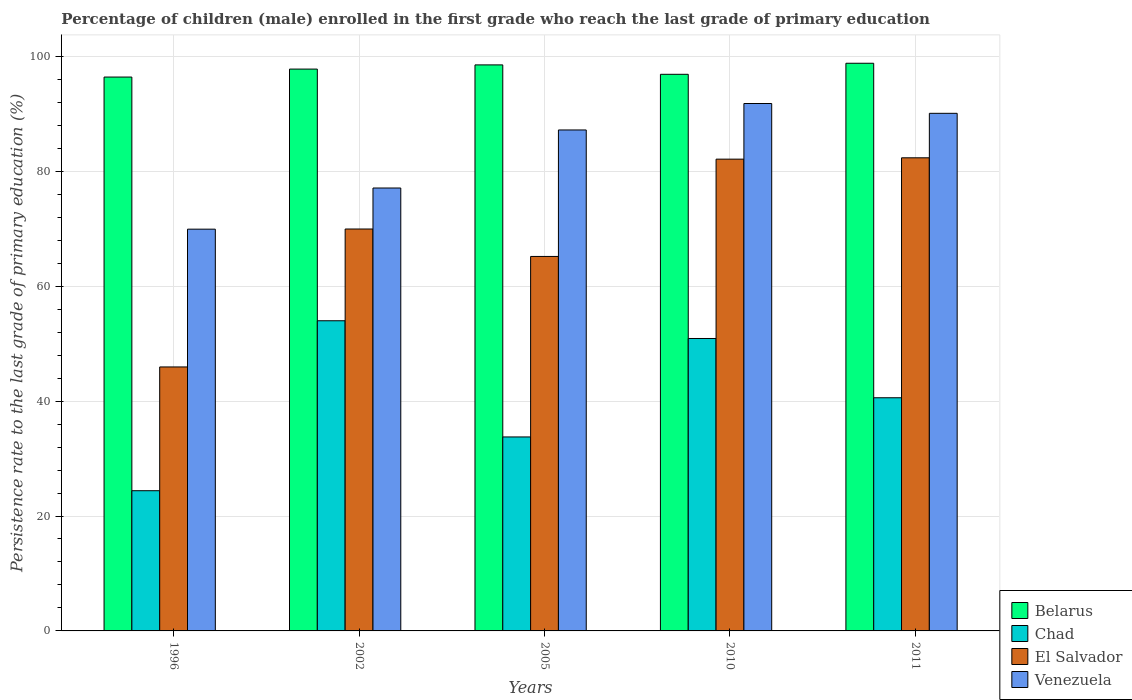Are the number of bars on each tick of the X-axis equal?
Offer a terse response. Yes. How many bars are there on the 4th tick from the left?
Give a very brief answer. 4. How many bars are there on the 2nd tick from the right?
Your response must be concise. 4. What is the label of the 1st group of bars from the left?
Provide a succinct answer. 1996. What is the persistence rate of children in Venezuela in 2011?
Give a very brief answer. 90.09. Across all years, what is the maximum persistence rate of children in Chad?
Your answer should be very brief. 53.99. Across all years, what is the minimum persistence rate of children in Chad?
Your answer should be compact. 24.4. In which year was the persistence rate of children in El Salvador maximum?
Make the answer very short. 2011. What is the total persistence rate of children in Chad in the graph?
Ensure brevity in your answer.  203.63. What is the difference between the persistence rate of children in Chad in 1996 and that in 2002?
Offer a very short reply. -29.58. What is the difference between the persistence rate of children in El Salvador in 2011 and the persistence rate of children in Venezuela in 2002?
Offer a very short reply. 5.26. What is the average persistence rate of children in Venezuela per year?
Your answer should be compact. 83.22. In the year 2011, what is the difference between the persistence rate of children in Chad and persistence rate of children in Venezuela?
Provide a short and direct response. -49.51. What is the ratio of the persistence rate of children in Belarus in 2002 to that in 2010?
Your answer should be very brief. 1.01. Is the persistence rate of children in Belarus in 2002 less than that in 2005?
Give a very brief answer. Yes. What is the difference between the highest and the second highest persistence rate of children in Belarus?
Give a very brief answer. 0.28. What is the difference between the highest and the lowest persistence rate of children in Venezuela?
Make the answer very short. 21.87. In how many years, is the persistence rate of children in Belarus greater than the average persistence rate of children in Belarus taken over all years?
Your answer should be compact. 3. Is it the case that in every year, the sum of the persistence rate of children in Venezuela and persistence rate of children in Belarus is greater than the sum of persistence rate of children in Chad and persistence rate of children in El Salvador?
Keep it short and to the point. No. What does the 3rd bar from the left in 2011 represents?
Keep it short and to the point. El Salvador. What does the 4th bar from the right in 2005 represents?
Your answer should be very brief. Belarus. Is it the case that in every year, the sum of the persistence rate of children in El Salvador and persistence rate of children in Belarus is greater than the persistence rate of children in Chad?
Keep it short and to the point. Yes. How many bars are there?
Your answer should be compact. 20. How many years are there in the graph?
Ensure brevity in your answer.  5. What is the difference between two consecutive major ticks on the Y-axis?
Your answer should be very brief. 20. Are the values on the major ticks of Y-axis written in scientific E-notation?
Provide a short and direct response. No. Does the graph contain any zero values?
Make the answer very short. No. Does the graph contain grids?
Ensure brevity in your answer.  Yes. What is the title of the graph?
Provide a short and direct response. Percentage of children (male) enrolled in the first grade who reach the last grade of primary education. What is the label or title of the Y-axis?
Provide a succinct answer. Persistence rate to the last grade of primary education (%). What is the Persistence rate to the last grade of primary education (%) in Belarus in 1996?
Your answer should be compact. 96.4. What is the Persistence rate to the last grade of primary education (%) of Chad in 1996?
Your answer should be compact. 24.4. What is the Persistence rate to the last grade of primary education (%) of El Salvador in 1996?
Make the answer very short. 45.94. What is the Persistence rate to the last grade of primary education (%) in Venezuela in 1996?
Provide a short and direct response. 69.92. What is the Persistence rate to the last grade of primary education (%) of Belarus in 2002?
Make the answer very short. 97.79. What is the Persistence rate to the last grade of primary education (%) of Chad in 2002?
Make the answer very short. 53.99. What is the Persistence rate to the last grade of primary education (%) of El Salvador in 2002?
Offer a terse response. 69.95. What is the Persistence rate to the last grade of primary education (%) in Venezuela in 2002?
Ensure brevity in your answer.  77.09. What is the Persistence rate to the last grade of primary education (%) in Belarus in 2005?
Make the answer very short. 98.52. What is the Persistence rate to the last grade of primary education (%) of Chad in 2005?
Give a very brief answer. 33.76. What is the Persistence rate to the last grade of primary education (%) of El Salvador in 2005?
Ensure brevity in your answer.  65.18. What is the Persistence rate to the last grade of primary education (%) in Venezuela in 2005?
Your answer should be compact. 87.19. What is the Persistence rate to the last grade of primary education (%) of Belarus in 2010?
Ensure brevity in your answer.  96.88. What is the Persistence rate to the last grade of primary education (%) in Chad in 2010?
Your answer should be compact. 50.9. What is the Persistence rate to the last grade of primary education (%) in El Salvador in 2010?
Keep it short and to the point. 82.11. What is the Persistence rate to the last grade of primary education (%) of Venezuela in 2010?
Make the answer very short. 91.8. What is the Persistence rate to the last grade of primary education (%) in Belarus in 2011?
Ensure brevity in your answer.  98.8. What is the Persistence rate to the last grade of primary education (%) in Chad in 2011?
Your answer should be very brief. 40.58. What is the Persistence rate to the last grade of primary education (%) in El Salvador in 2011?
Provide a succinct answer. 82.35. What is the Persistence rate to the last grade of primary education (%) in Venezuela in 2011?
Your answer should be very brief. 90.09. Across all years, what is the maximum Persistence rate to the last grade of primary education (%) of Belarus?
Provide a short and direct response. 98.8. Across all years, what is the maximum Persistence rate to the last grade of primary education (%) of Chad?
Ensure brevity in your answer.  53.99. Across all years, what is the maximum Persistence rate to the last grade of primary education (%) of El Salvador?
Make the answer very short. 82.35. Across all years, what is the maximum Persistence rate to the last grade of primary education (%) in Venezuela?
Give a very brief answer. 91.8. Across all years, what is the minimum Persistence rate to the last grade of primary education (%) of Belarus?
Offer a very short reply. 96.4. Across all years, what is the minimum Persistence rate to the last grade of primary education (%) in Chad?
Your answer should be compact. 24.4. Across all years, what is the minimum Persistence rate to the last grade of primary education (%) in El Salvador?
Your response must be concise. 45.94. Across all years, what is the minimum Persistence rate to the last grade of primary education (%) of Venezuela?
Your response must be concise. 69.92. What is the total Persistence rate to the last grade of primary education (%) of Belarus in the graph?
Offer a terse response. 488.39. What is the total Persistence rate to the last grade of primary education (%) in Chad in the graph?
Your answer should be compact. 203.63. What is the total Persistence rate to the last grade of primary education (%) in El Salvador in the graph?
Offer a very short reply. 345.53. What is the total Persistence rate to the last grade of primary education (%) of Venezuela in the graph?
Give a very brief answer. 416.09. What is the difference between the Persistence rate to the last grade of primary education (%) in Belarus in 1996 and that in 2002?
Provide a succinct answer. -1.39. What is the difference between the Persistence rate to the last grade of primary education (%) of Chad in 1996 and that in 2002?
Make the answer very short. -29.58. What is the difference between the Persistence rate to the last grade of primary education (%) in El Salvador in 1996 and that in 2002?
Provide a succinct answer. -24.01. What is the difference between the Persistence rate to the last grade of primary education (%) of Venezuela in 1996 and that in 2002?
Keep it short and to the point. -7.16. What is the difference between the Persistence rate to the last grade of primary education (%) of Belarus in 1996 and that in 2005?
Your response must be concise. -2.12. What is the difference between the Persistence rate to the last grade of primary education (%) in Chad in 1996 and that in 2005?
Your answer should be very brief. -9.36. What is the difference between the Persistence rate to the last grade of primary education (%) of El Salvador in 1996 and that in 2005?
Offer a terse response. -19.23. What is the difference between the Persistence rate to the last grade of primary education (%) of Venezuela in 1996 and that in 2005?
Your response must be concise. -17.27. What is the difference between the Persistence rate to the last grade of primary education (%) in Belarus in 1996 and that in 2010?
Ensure brevity in your answer.  -0.48. What is the difference between the Persistence rate to the last grade of primary education (%) of Chad in 1996 and that in 2010?
Give a very brief answer. -26.49. What is the difference between the Persistence rate to the last grade of primary education (%) in El Salvador in 1996 and that in 2010?
Keep it short and to the point. -36.17. What is the difference between the Persistence rate to the last grade of primary education (%) of Venezuela in 1996 and that in 2010?
Your answer should be very brief. -21.87. What is the difference between the Persistence rate to the last grade of primary education (%) of Belarus in 1996 and that in 2011?
Provide a short and direct response. -2.4. What is the difference between the Persistence rate to the last grade of primary education (%) of Chad in 1996 and that in 2011?
Keep it short and to the point. -16.18. What is the difference between the Persistence rate to the last grade of primary education (%) in El Salvador in 1996 and that in 2011?
Offer a very short reply. -36.4. What is the difference between the Persistence rate to the last grade of primary education (%) in Venezuela in 1996 and that in 2011?
Offer a terse response. -20.16. What is the difference between the Persistence rate to the last grade of primary education (%) of Belarus in 2002 and that in 2005?
Offer a very short reply. -0.73. What is the difference between the Persistence rate to the last grade of primary education (%) of Chad in 2002 and that in 2005?
Provide a succinct answer. 20.22. What is the difference between the Persistence rate to the last grade of primary education (%) in El Salvador in 2002 and that in 2005?
Make the answer very short. 4.78. What is the difference between the Persistence rate to the last grade of primary education (%) of Venezuela in 2002 and that in 2005?
Give a very brief answer. -10.1. What is the difference between the Persistence rate to the last grade of primary education (%) of Belarus in 2002 and that in 2010?
Offer a terse response. 0.91. What is the difference between the Persistence rate to the last grade of primary education (%) of Chad in 2002 and that in 2010?
Your response must be concise. 3.09. What is the difference between the Persistence rate to the last grade of primary education (%) of El Salvador in 2002 and that in 2010?
Provide a succinct answer. -12.16. What is the difference between the Persistence rate to the last grade of primary education (%) of Venezuela in 2002 and that in 2010?
Provide a short and direct response. -14.71. What is the difference between the Persistence rate to the last grade of primary education (%) of Belarus in 2002 and that in 2011?
Ensure brevity in your answer.  -1.01. What is the difference between the Persistence rate to the last grade of primary education (%) in Chad in 2002 and that in 2011?
Give a very brief answer. 13.4. What is the difference between the Persistence rate to the last grade of primary education (%) of El Salvador in 2002 and that in 2011?
Your response must be concise. -12.39. What is the difference between the Persistence rate to the last grade of primary education (%) in Venezuela in 2002 and that in 2011?
Provide a short and direct response. -13. What is the difference between the Persistence rate to the last grade of primary education (%) in Belarus in 2005 and that in 2010?
Your response must be concise. 1.64. What is the difference between the Persistence rate to the last grade of primary education (%) in Chad in 2005 and that in 2010?
Offer a very short reply. -17.14. What is the difference between the Persistence rate to the last grade of primary education (%) of El Salvador in 2005 and that in 2010?
Offer a terse response. -16.93. What is the difference between the Persistence rate to the last grade of primary education (%) of Venezuela in 2005 and that in 2010?
Make the answer very short. -4.6. What is the difference between the Persistence rate to the last grade of primary education (%) in Belarus in 2005 and that in 2011?
Your response must be concise. -0.28. What is the difference between the Persistence rate to the last grade of primary education (%) of Chad in 2005 and that in 2011?
Provide a succinct answer. -6.82. What is the difference between the Persistence rate to the last grade of primary education (%) in El Salvador in 2005 and that in 2011?
Provide a succinct answer. -17.17. What is the difference between the Persistence rate to the last grade of primary education (%) in Venezuela in 2005 and that in 2011?
Ensure brevity in your answer.  -2.9. What is the difference between the Persistence rate to the last grade of primary education (%) of Belarus in 2010 and that in 2011?
Your response must be concise. -1.92. What is the difference between the Persistence rate to the last grade of primary education (%) in Chad in 2010 and that in 2011?
Provide a short and direct response. 10.31. What is the difference between the Persistence rate to the last grade of primary education (%) in El Salvador in 2010 and that in 2011?
Offer a very short reply. -0.24. What is the difference between the Persistence rate to the last grade of primary education (%) of Venezuela in 2010 and that in 2011?
Give a very brief answer. 1.71. What is the difference between the Persistence rate to the last grade of primary education (%) in Belarus in 1996 and the Persistence rate to the last grade of primary education (%) in Chad in 2002?
Offer a very short reply. 42.42. What is the difference between the Persistence rate to the last grade of primary education (%) of Belarus in 1996 and the Persistence rate to the last grade of primary education (%) of El Salvador in 2002?
Ensure brevity in your answer.  26.45. What is the difference between the Persistence rate to the last grade of primary education (%) in Belarus in 1996 and the Persistence rate to the last grade of primary education (%) in Venezuela in 2002?
Provide a succinct answer. 19.31. What is the difference between the Persistence rate to the last grade of primary education (%) in Chad in 1996 and the Persistence rate to the last grade of primary education (%) in El Salvador in 2002?
Give a very brief answer. -45.55. What is the difference between the Persistence rate to the last grade of primary education (%) of Chad in 1996 and the Persistence rate to the last grade of primary education (%) of Venezuela in 2002?
Provide a short and direct response. -52.69. What is the difference between the Persistence rate to the last grade of primary education (%) of El Salvador in 1996 and the Persistence rate to the last grade of primary education (%) of Venezuela in 2002?
Give a very brief answer. -31.15. What is the difference between the Persistence rate to the last grade of primary education (%) in Belarus in 1996 and the Persistence rate to the last grade of primary education (%) in Chad in 2005?
Provide a short and direct response. 62.64. What is the difference between the Persistence rate to the last grade of primary education (%) in Belarus in 1996 and the Persistence rate to the last grade of primary education (%) in El Salvador in 2005?
Keep it short and to the point. 31.22. What is the difference between the Persistence rate to the last grade of primary education (%) of Belarus in 1996 and the Persistence rate to the last grade of primary education (%) of Venezuela in 2005?
Ensure brevity in your answer.  9.21. What is the difference between the Persistence rate to the last grade of primary education (%) in Chad in 1996 and the Persistence rate to the last grade of primary education (%) in El Salvador in 2005?
Offer a terse response. -40.77. What is the difference between the Persistence rate to the last grade of primary education (%) in Chad in 1996 and the Persistence rate to the last grade of primary education (%) in Venezuela in 2005?
Your answer should be compact. -62.79. What is the difference between the Persistence rate to the last grade of primary education (%) of El Salvador in 1996 and the Persistence rate to the last grade of primary education (%) of Venezuela in 2005?
Offer a terse response. -41.25. What is the difference between the Persistence rate to the last grade of primary education (%) of Belarus in 1996 and the Persistence rate to the last grade of primary education (%) of Chad in 2010?
Your answer should be very brief. 45.5. What is the difference between the Persistence rate to the last grade of primary education (%) in Belarus in 1996 and the Persistence rate to the last grade of primary education (%) in El Salvador in 2010?
Provide a succinct answer. 14.29. What is the difference between the Persistence rate to the last grade of primary education (%) of Belarus in 1996 and the Persistence rate to the last grade of primary education (%) of Venezuela in 2010?
Your response must be concise. 4.6. What is the difference between the Persistence rate to the last grade of primary education (%) of Chad in 1996 and the Persistence rate to the last grade of primary education (%) of El Salvador in 2010?
Provide a succinct answer. -57.71. What is the difference between the Persistence rate to the last grade of primary education (%) of Chad in 1996 and the Persistence rate to the last grade of primary education (%) of Venezuela in 2010?
Make the answer very short. -67.39. What is the difference between the Persistence rate to the last grade of primary education (%) in El Salvador in 1996 and the Persistence rate to the last grade of primary education (%) in Venezuela in 2010?
Offer a terse response. -45.85. What is the difference between the Persistence rate to the last grade of primary education (%) of Belarus in 1996 and the Persistence rate to the last grade of primary education (%) of Chad in 2011?
Offer a terse response. 55.82. What is the difference between the Persistence rate to the last grade of primary education (%) of Belarus in 1996 and the Persistence rate to the last grade of primary education (%) of El Salvador in 2011?
Your answer should be compact. 14.05. What is the difference between the Persistence rate to the last grade of primary education (%) of Belarus in 1996 and the Persistence rate to the last grade of primary education (%) of Venezuela in 2011?
Your answer should be compact. 6.31. What is the difference between the Persistence rate to the last grade of primary education (%) in Chad in 1996 and the Persistence rate to the last grade of primary education (%) in El Salvador in 2011?
Provide a succinct answer. -57.94. What is the difference between the Persistence rate to the last grade of primary education (%) in Chad in 1996 and the Persistence rate to the last grade of primary education (%) in Venezuela in 2011?
Your response must be concise. -65.69. What is the difference between the Persistence rate to the last grade of primary education (%) in El Salvador in 1996 and the Persistence rate to the last grade of primary education (%) in Venezuela in 2011?
Provide a succinct answer. -44.14. What is the difference between the Persistence rate to the last grade of primary education (%) of Belarus in 2002 and the Persistence rate to the last grade of primary education (%) of Chad in 2005?
Your answer should be compact. 64.03. What is the difference between the Persistence rate to the last grade of primary education (%) of Belarus in 2002 and the Persistence rate to the last grade of primary education (%) of El Salvador in 2005?
Make the answer very short. 32.61. What is the difference between the Persistence rate to the last grade of primary education (%) of Belarus in 2002 and the Persistence rate to the last grade of primary education (%) of Venezuela in 2005?
Provide a short and direct response. 10.6. What is the difference between the Persistence rate to the last grade of primary education (%) of Chad in 2002 and the Persistence rate to the last grade of primary education (%) of El Salvador in 2005?
Provide a short and direct response. -11.19. What is the difference between the Persistence rate to the last grade of primary education (%) of Chad in 2002 and the Persistence rate to the last grade of primary education (%) of Venezuela in 2005?
Ensure brevity in your answer.  -33.21. What is the difference between the Persistence rate to the last grade of primary education (%) of El Salvador in 2002 and the Persistence rate to the last grade of primary education (%) of Venezuela in 2005?
Give a very brief answer. -17.24. What is the difference between the Persistence rate to the last grade of primary education (%) of Belarus in 2002 and the Persistence rate to the last grade of primary education (%) of Chad in 2010?
Offer a terse response. 46.89. What is the difference between the Persistence rate to the last grade of primary education (%) of Belarus in 2002 and the Persistence rate to the last grade of primary education (%) of El Salvador in 2010?
Give a very brief answer. 15.68. What is the difference between the Persistence rate to the last grade of primary education (%) in Belarus in 2002 and the Persistence rate to the last grade of primary education (%) in Venezuela in 2010?
Your answer should be very brief. 5.99. What is the difference between the Persistence rate to the last grade of primary education (%) in Chad in 2002 and the Persistence rate to the last grade of primary education (%) in El Salvador in 2010?
Offer a very short reply. -28.13. What is the difference between the Persistence rate to the last grade of primary education (%) in Chad in 2002 and the Persistence rate to the last grade of primary education (%) in Venezuela in 2010?
Make the answer very short. -37.81. What is the difference between the Persistence rate to the last grade of primary education (%) of El Salvador in 2002 and the Persistence rate to the last grade of primary education (%) of Venezuela in 2010?
Your response must be concise. -21.84. What is the difference between the Persistence rate to the last grade of primary education (%) of Belarus in 2002 and the Persistence rate to the last grade of primary education (%) of Chad in 2011?
Your answer should be very brief. 57.2. What is the difference between the Persistence rate to the last grade of primary education (%) in Belarus in 2002 and the Persistence rate to the last grade of primary education (%) in El Salvador in 2011?
Offer a very short reply. 15.44. What is the difference between the Persistence rate to the last grade of primary education (%) of Belarus in 2002 and the Persistence rate to the last grade of primary education (%) of Venezuela in 2011?
Ensure brevity in your answer.  7.7. What is the difference between the Persistence rate to the last grade of primary education (%) of Chad in 2002 and the Persistence rate to the last grade of primary education (%) of El Salvador in 2011?
Your answer should be very brief. -28.36. What is the difference between the Persistence rate to the last grade of primary education (%) in Chad in 2002 and the Persistence rate to the last grade of primary education (%) in Venezuela in 2011?
Your response must be concise. -36.1. What is the difference between the Persistence rate to the last grade of primary education (%) in El Salvador in 2002 and the Persistence rate to the last grade of primary education (%) in Venezuela in 2011?
Offer a very short reply. -20.13. What is the difference between the Persistence rate to the last grade of primary education (%) of Belarus in 2005 and the Persistence rate to the last grade of primary education (%) of Chad in 2010?
Your response must be concise. 47.62. What is the difference between the Persistence rate to the last grade of primary education (%) in Belarus in 2005 and the Persistence rate to the last grade of primary education (%) in El Salvador in 2010?
Provide a short and direct response. 16.41. What is the difference between the Persistence rate to the last grade of primary education (%) in Belarus in 2005 and the Persistence rate to the last grade of primary education (%) in Venezuela in 2010?
Provide a succinct answer. 6.72. What is the difference between the Persistence rate to the last grade of primary education (%) of Chad in 2005 and the Persistence rate to the last grade of primary education (%) of El Salvador in 2010?
Provide a succinct answer. -48.35. What is the difference between the Persistence rate to the last grade of primary education (%) of Chad in 2005 and the Persistence rate to the last grade of primary education (%) of Venezuela in 2010?
Your response must be concise. -58.04. What is the difference between the Persistence rate to the last grade of primary education (%) in El Salvador in 2005 and the Persistence rate to the last grade of primary education (%) in Venezuela in 2010?
Offer a very short reply. -26.62. What is the difference between the Persistence rate to the last grade of primary education (%) of Belarus in 2005 and the Persistence rate to the last grade of primary education (%) of Chad in 2011?
Ensure brevity in your answer.  57.93. What is the difference between the Persistence rate to the last grade of primary education (%) in Belarus in 2005 and the Persistence rate to the last grade of primary education (%) in El Salvador in 2011?
Your answer should be compact. 16.17. What is the difference between the Persistence rate to the last grade of primary education (%) in Belarus in 2005 and the Persistence rate to the last grade of primary education (%) in Venezuela in 2011?
Your answer should be compact. 8.43. What is the difference between the Persistence rate to the last grade of primary education (%) in Chad in 2005 and the Persistence rate to the last grade of primary education (%) in El Salvador in 2011?
Make the answer very short. -48.59. What is the difference between the Persistence rate to the last grade of primary education (%) in Chad in 2005 and the Persistence rate to the last grade of primary education (%) in Venezuela in 2011?
Make the answer very short. -56.33. What is the difference between the Persistence rate to the last grade of primary education (%) of El Salvador in 2005 and the Persistence rate to the last grade of primary education (%) of Venezuela in 2011?
Your response must be concise. -24.91. What is the difference between the Persistence rate to the last grade of primary education (%) of Belarus in 2010 and the Persistence rate to the last grade of primary education (%) of Chad in 2011?
Provide a succinct answer. 56.29. What is the difference between the Persistence rate to the last grade of primary education (%) in Belarus in 2010 and the Persistence rate to the last grade of primary education (%) in El Salvador in 2011?
Offer a terse response. 14.53. What is the difference between the Persistence rate to the last grade of primary education (%) of Belarus in 2010 and the Persistence rate to the last grade of primary education (%) of Venezuela in 2011?
Your response must be concise. 6.79. What is the difference between the Persistence rate to the last grade of primary education (%) in Chad in 2010 and the Persistence rate to the last grade of primary education (%) in El Salvador in 2011?
Provide a short and direct response. -31.45. What is the difference between the Persistence rate to the last grade of primary education (%) of Chad in 2010 and the Persistence rate to the last grade of primary education (%) of Venezuela in 2011?
Give a very brief answer. -39.19. What is the difference between the Persistence rate to the last grade of primary education (%) in El Salvador in 2010 and the Persistence rate to the last grade of primary education (%) in Venezuela in 2011?
Offer a terse response. -7.98. What is the average Persistence rate to the last grade of primary education (%) of Belarus per year?
Ensure brevity in your answer.  97.68. What is the average Persistence rate to the last grade of primary education (%) in Chad per year?
Make the answer very short. 40.73. What is the average Persistence rate to the last grade of primary education (%) of El Salvador per year?
Ensure brevity in your answer.  69.11. What is the average Persistence rate to the last grade of primary education (%) of Venezuela per year?
Give a very brief answer. 83.22. In the year 1996, what is the difference between the Persistence rate to the last grade of primary education (%) of Belarus and Persistence rate to the last grade of primary education (%) of Chad?
Keep it short and to the point. 72. In the year 1996, what is the difference between the Persistence rate to the last grade of primary education (%) of Belarus and Persistence rate to the last grade of primary education (%) of El Salvador?
Provide a succinct answer. 50.46. In the year 1996, what is the difference between the Persistence rate to the last grade of primary education (%) of Belarus and Persistence rate to the last grade of primary education (%) of Venezuela?
Your answer should be compact. 26.48. In the year 1996, what is the difference between the Persistence rate to the last grade of primary education (%) in Chad and Persistence rate to the last grade of primary education (%) in El Salvador?
Ensure brevity in your answer.  -21.54. In the year 1996, what is the difference between the Persistence rate to the last grade of primary education (%) of Chad and Persistence rate to the last grade of primary education (%) of Venezuela?
Your answer should be compact. -45.52. In the year 1996, what is the difference between the Persistence rate to the last grade of primary education (%) of El Salvador and Persistence rate to the last grade of primary education (%) of Venezuela?
Provide a short and direct response. -23.98. In the year 2002, what is the difference between the Persistence rate to the last grade of primary education (%) of Belarus and Persistence rate to the last grade of primary education (%) of Chad?
Your answer should be compact. 43.8. In the year 2002, what is the difference between the Persistence rate to the last grade of primary education (%) of Belarus and Persistence rate to the last grade of primary education (%) of El Salvador?
Your answer should be very brief. 27.83. In the year 2002, what is the difference between the Persistence rate to the last grade of primary education (%) in Belarus and Persistence rate to the last grade of primary education (%) in Venezuela?
Your response must be concise. 20.7. In the year 2002, what is the difference between the Persistence rate to the last grade of primary education (%) in Chad and Persistence rate to the last grade of primary education (%) in El Salvador?
Make the answer very short. -15.97. In the year 2002, what is the difference between the Persistence rate to the last grade of primary education (%) of Chad and Persistence rate to the last grade of primary education (%) of Venezuela?
Your response must be concise. -23.1. In the year 2002, what is the difference between the Persistence rate to the last grade of primary education (%) in El Salvador and Persistence rate to the last grade of primary education (%) in Venezuela?
Give a very brief answer. -7.14. In the year 2005, what is the difference between the Persistence rate to the last grade of primary education (%) in Belarus and Persistence rate to the last grade of primary education (%) in Chad?
Make the answer very short. 64.76. In the year 2005, what is the difference between the Persistence rate to the last grade of primary education (%) of Belarus and Persistence rate to the last grade of primary education (%) of El Salvador?
Keep it short and to the point. 33.34. In the year 2005, what is the difference between the Persistence rate to the last grade of primary education (%) in Belarus and Persistence rate to the last grade of primary education (%) in Venezuela?
Your response must be concise. 11.33. In the year 2005, what is the difference between the Persistence rate to the last grade of primary education (%) of Chad and Persistence rate to the last grade of primary education (%) of El Salvador?
Your response must be concise. -31.42. In the year 2005, what is the difference between the Persistence rate to the last grade of primary education (%) of Chad and Persistence rate to the last grade of primary education (%) of Venezuela?
Ensure brevity in your answer.  -53.43. In the year 2005, what is the difference between the Persistence rate to the last grade of primary education (%) of El Salvador and Persistence rate to the last grade of primary education (%) of Venezuela?
Your answer should be very brief. -22.01. In the year 2010, what is the difference between the Persistence rate to the last grade of primary education (%) in Belarus and Persistence rate to the last grade of primary education (%) in Chad?
Keep it short and to the point. 45.98. In the year 2010, what is the difference between the Persistence rate to the last grade of primary education (%) in Belarus and Persistence rate to the last grade of primary education (%) in El Salvador?
Provide a short and direct response. 14.77. In the year 2010, what is the difference between the Persistence rate to the last grade of primary education (%) in Belarus and Persistence rate to the last grade of primary education (%) in Venezuela?
Keep it short and to the point. 5.08. In the year 2010, what is the difference between the Persistence rate to the last grade of primary education (%) of Chad and Persistence rate to the last grade of primary education (%) of El Salvador?
Ensure brevity in your answer.  -31.21. In the year 2010, what is the difference between the Persistence rate to the last grade of primary education (%) of Chad and Persistence rate to the last grade of primary education (%) of Venezuela?
Your answer should be compact. -40.9. In the year 2010, what is the difference between the Persistence rate to the last grade of primary education (%) of El Salvador and Persistence rate to the last grade of primary education (%) of Venezuela?
Offer a very short reply. -9.69. In the year 2011, what is the difference between the Persistence rate to the last grade of primary education (%) of Belarus and Persistence rate to the last grade of primary education (%) of Chad?
Offer a very short reply. 58.22. In the year 2011, what is the difference between the Persistence rate to the last grade of primary education (%) of Belarus and Persistence rate to the last grade of primary education (%) of El Salvador?
Offer a terse response. 16.45. In the year 2011, what is the difference between the Persistence rate to the last grade of primary education (%) of Belarus and Persistence rate to the last grade of primary education (%) of Venezuela?
Provide a succinct answer. 8.71. In the year 2011, what is the difference between the Persistence rate to the last grade of primary education (%) of Chad and Persistence rate to the last grade of primary education (%) of El Salvador?
Keep it short and to the point. -41.76. In the year 2011, what is the difference between the Persistence rate to the last grade of primary education (%) in Chad and Persistence rate to the last grade of primary education (%) in Venezuela?
Provide a succinct answer. -49.51. In the year 2011, what is the difference between the Persistence rate to the last grade of primary education (%) of El Salvador and Persistence rate to the last grade of primary education (%) of Venezuela?
Provide a short and direct response. -7.74. What is the ratio of the Persistence rate to the last grade of primary education (%) of Belarus in 1996 to that in 2002?
Ensure brevity in your answer.  0.99. What is the ratio of the Persistence rate to the last grade of primary education (%) in Chad in 1996 to that in 2002?
Your answer should be compact. 0.45. What is the ratio of the Persistence rate to the last grade of primary education (%) in El Salvador in 1996 to that in 2002?
Ensure brevity in your answer.  0.66. What is the ratio of the Persistence rate to the last grade of primary education (%) of Venezuela in 1996 to that in 2002?
Ensure brevity in your answer.  0.91. What is the ratio of the Persistence rate to the last grade of primary education (%) in Belarus in 1996 to that in 2005?
Give a very brief answer. 0.98. What is the ratio of the Persistence rate to the last grade of primary education (%) in Chad in 1996 to that in 2005?
Offer a terse response. 0.72. What is the ratio of the Persistence rate to the last grade of primary education (%) of El Salvador in 1996 to that in 2005?
Offer a very short reply. 0.7. What is the ratio of the Persistence rate to the last grade of primary education (%) of Venezuela in 1996 to that in 2005?
Provide a short and direct response. 0.8. What is the ratio of the Persistence rate to the last grade of primary education (%) of Chad in 1996 to that in 2010?
Keep it short and to the point. 0.48. What is the ratio of the Persistence rate to the last grade of primary education (%) in El Salvador in 1996 to that in 2010?
Ensure brevity in your answer.  0.56. What is the ratio of the Persistence rate to the last grade of primary education (%) of Venezuela in 1996 to that in 2010?
Offer a very short reply. 0.76. What is the ratio of the Persistence rate to the last grade of primary education (%) in Belarus in 1996 to that in 2011?
Your answer should be very brief. 0.98. What is the ratio of the Persistence rate to the last grade of primary education (%) in Chad in 1996 to that in 2011?
Your response must be concise. 0.6. What is the ratio of the Persistence rate to the last grade of primary education (%) in El Salvador in 1996 to that in 2011?
Give a very brief answer. 0.56. What is the ratio of the Persistence rate to the last grade of primary education (%) in Venezuela in 1996 to that in 2011?
Your answer should be very brief. 0.78. What is the ratio of the Persistence rate to the last grade of primary education (%) in Belarus in 2002 to that in 2005?
Your response must be concise. 0.99. What is the ratio of the Persistence rate to the last grade of primary education (%) of Chad in 2002 to that in 2005?
Keep it short and to the point. 1.6. What is the ratio of the Persistence rate to the last grade of primary education (%) of El Salvador in 2002 to that in 2005?
Ensure brevity in your answer.  1.07. What is the ratio of the Persistence rate to the last grade of primary education (%) of Venezuela in 2002 to that in 2005?
Provide a short and direct response. 0.88. What is the ratio of the Persistence rate to the last grade of primary education (%) in Belarus in 2002 to that in 2010?
Ensure brevity in your answer.  1.01. What is the ratio of the Persistence rate to the last grade of primary education (%) of Chad in 2002 to that in 2010?
Offer a terse response. 1.06. What is the ratio of the Persistence rate to the last grade of primary education (%) in El Salvador in 2002 to that in 2010?
Keep it short and to the point. 0.85. What is the ratio of the Persistence rate to the last grade of primary education (%) of Venezuela in 2002 to that in 2010?
Offer a terse response. 0.84. What is the ratio of the Persistence rate to the last grade of primary education (%) of Belarus in 2002 to that in 2011?
Ensure brevity in your answer.  0.99. What is the ratio of the Persistence rate to the last grade of primary education (%) in Chad in 2002 to that in 2011?
Provide a short and direct response. 1.33. What is the ratio of the Persistence rate to the last grade of primary education (%) of El Salvador in 2002 to that in 2011?
Your response must be concise. 0.85. What is the ratio of the Persistence rate to the last grade of primary education (%) in Venezuela in 2002 to that in 2011?
Offer a very short reply. 0.86. What is the ratio of the Persistence rate to the last grade of primary education (%) of Belarus in 2005 to that in 2010?
Provide a succinct answer. 1.02. What is the ratio of the Persistence rate to the last grade of primary education (%) of Chad in 2005 to that in 2010?
Your response must be concise. 0.66. What is the ratio of the Persistence rate to the last grade of primary education (%) of El Salvador in 2005 to that in 2010?
Make the answer very short. 0.79. What is the ratio of the Persistence rate to the last grade of primary education (%) in Venezuela in 2005 to that in 2010?
Provide a succinct answer. 0.95. What is the ratio of the Persistence rate to the last grade of primary education (%) in Belarus in 2005 to that in 2011?
Your answer should be compact. 1. What is the ratio of the Persistence rate to the last grade of primary education (%) of Chad in 2005 to that in 2011?
Offer a terse response. 0.83. What is the ratio of the Persistence rate to the last grade of primary education (%) of El Salvador in 2005 to that in 2011?
Offer a terse response. 0.79. What is the ratio of the Persistence rate to the last grade of primary education (%) of Venezuela in 2005 to that in 2011?
Keep it short and to the point. 0.97. What is the ratio of the Persistence rate to the last grade of primary education (%) of Belarus in 2010 to that in 2011?
Give a very brief answer. 0.98. What is the ratio of the Persistence rate to the last grade of primary education (%) of Chad in 2010 to that in 2011?
Make the answer very short. 1.25. What is the difference between the highest and the second highest Persistence rate to the last grade of primary education (%) in Belarus?
Your answer should be compact. 0.28. What is the difference between the highest and the second highest Persistence rate to the last grade of primary education (%) of Chad?
Keep it short and to the point. 3.09. What is the difference between the highest and the second highest Persistence rate to the last grade of primary education (%) of El Salvador?
Give a very brief answer. 0.24. What is the difference between the highest and the second highest Persistence rate to the last grade of primary education (%) of Venezuela?
Keep it short and to the point. 1.71. What is the difference between the highest and the lowest Persistence rate to the last grade of primary education (%) in Belarus?
Offer a very short reply. 2.4. What is the difference between the highest and the lowest Persistence rate to the last grade of primary education (%) of Chad?
Give a very brief answer. 29.58. What is the difference between the highest and the lowest Persistence rate to the last grade of primary education (%) in El Salvador?
Provide a short and direct response. 36.4. What is the difference between the highest and the lowest Persistence rate to the last grade of primary education (%) in Venezuela?
Offer a terse response. 21.87. 